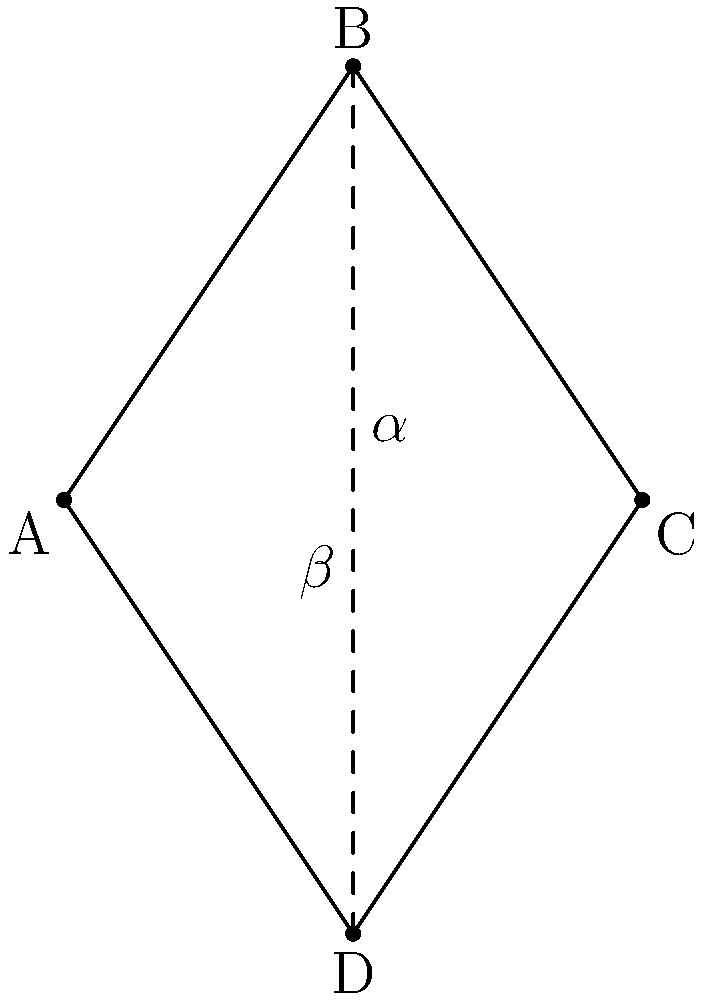In a chevron pattern used for a fashion design, two lines intersect to form angles $\alpha$ and $\beta$ as shown in the diagram. If the measure of angle $\alpha$ is 60°, what is the measure of angle $\beta$? Let's approach this step-by-step:

1) In the diagram, we can see that lines BD forms two pairs of vertical angles: 
   - One pair at the top and bottom of the chevron
   - Another pair on the left and right sides of the chevron

2) A fundamental property of vertical angles is that they are always congruent (equal in measure).

3) We're given that angle $\alpha$ measures 60°. Its vertical angle (the one opposite to it) will also measure 60°.

4) In any point where two straight lines intersect, the sum of the measures of the four angles formed is always 360°.

5) Let's call the measure of angle $\beta$ as x°. Then we can write an equation:

   $$60° + 60° + x° + x° = 360°$$

6) Simplifying:
   $$120° + 2x° = 360°$$

7) Subtracting 120° from both sides:
   $$2x° = 240°$$

8) Dividing both sides by 2:
   $$x° = 120°$$

Therefore, the measure of angle $\beta$ is 120°.
Answer: 120° 